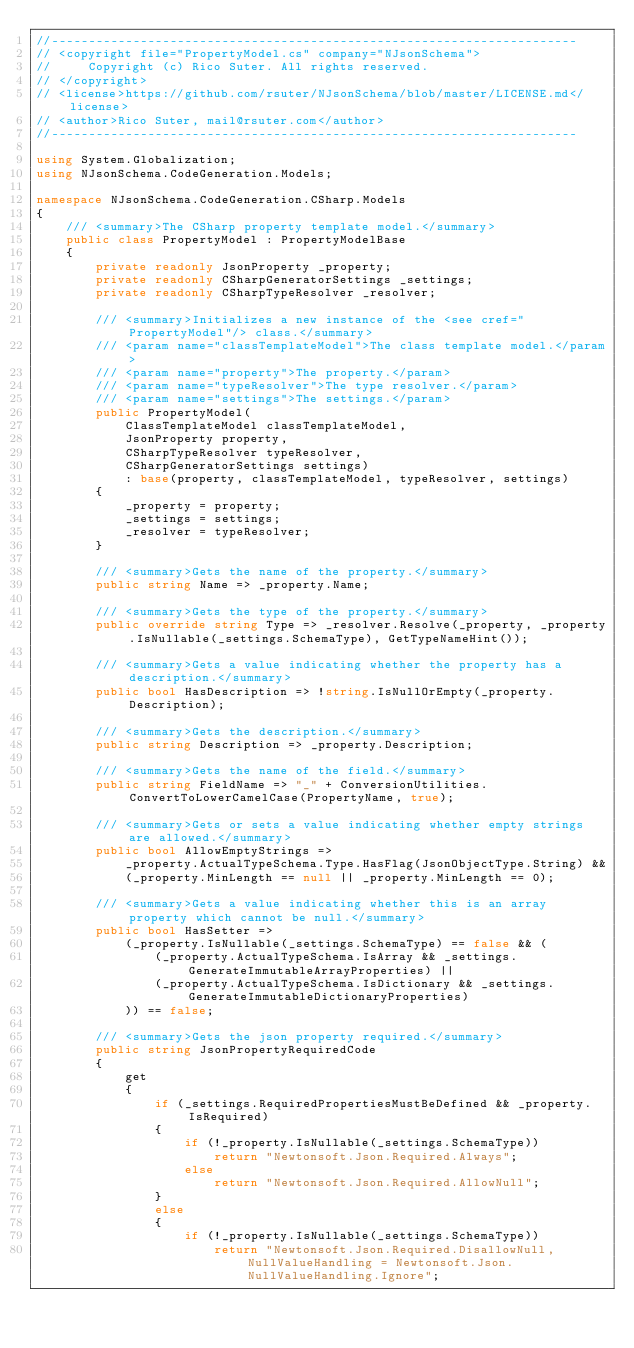<code> <loc_0><loc_0><loc_500><loc_500><_C#_>//-----------------------------------------------------------------------
// <copyright file="PropertyModel.cs" company="NJsonSchema">
//     Copyright (c) Rico Suter. All rights reserved.
// </copyright>
// <license>https://github.com/rsuter/NJsonSchema/blob/master/LICENSE.md</license>
// <author>Rico Suter, mail@rsuter.com</author>
//-----------------------------------------------------------------------

using System.Globalization;
using NJsonSchema.CodeGeneration.Models;

namespace NJsonSchema.CodeGeneration.CSharp.Models
{
    /// <summary>The CSharp property template model.</summary>
    public class PropertyModel : PropertyModelBase
    {
        private readonly JsonProperty _property;
        private readonly CSharpGeneratorSettings _settings;
        private readonly CSharpTypeResolver _resolver;

        /// <summary>Initializes a new instance of the <see cref="PropertyModel"/> class.</summary>
        /// <param name="classTemplateModel">The class template model.</param>
        /// <param name="property">The property.</param>
        /// <param name="typeResolver">The type resolver.</param>
        /// <param name="settings">The settings.</param>
        public PropertyModel(
            ClassTemplateModel classTemplateModel,
            JsonProperty property,
            CSharpTypeResolver typeResolver,
            CSharpGeneratorSettings settings)
            : base(property, classTemplateModel, typeResolver, settings)
        {
            _property = property;
            _settings = settings;
            _resolver = typeResolver;
        }

        /// <summary>Gets the name of the property.</summary>
        public string Name => _property.Name;

        /// <summary>Gets the type of the property.</summary>
        public override string Type => _resolver.Resolve(_property, _property.IsNullable(_settings.SchemaType), GetTypeNameHint());

        /// <summary>Gets a value indicating whether the property has a description.</summary>
        public bool HasDescription => !string.IsNullOrEmpty(_property.Description);

        /// <summary>Gets the description.</summary>
        public string Description => _property.Description;

        /// <summary>Gets the name of the field.</summary>
        public string FieldName => "_" + ConversionUtilities.ConvertToLowerCamelCase(PropertyName, true);

        /// <summary>Gets or sets a value indicating whether empty strings are allowed.</summary>
        public bool AllowEmptyStrings =>
            _property.ActualTypeSchema.Type.HasFlag(JsonObjectType.String) &&
            (_property.MinLength == null || _property.MinLength == 0);

        /// <summary>Gets a value indicating whether this is an array property which cannot be null.</summary>
        public bool HasSetter =>
            (_property.IsNullable(_settings.SchemaType) == false && (
                (_property.ActualTypeSchema.IsArray && _settings.GenerateImmutableArrayProperties) ||
                (_property.ActualTypeSchema.IsDictionary && _settings.GenerateImmutableDictionaryProperties)
            )) == false;

        /// <summary>Gets the json property required.</summary>
        public string JsonPropertyRequiredCode
        {
            get
            {
                if (_settings.RequiredPropertiesMustBeDefined && _property.IsRequired)
                {
                    if (!_property.IsNullable(_settings.SchemaType))
                        return "Newtonsoft.Json.Required.Always";
                    else
                        return "Newtonsoft.Json.Required.AllowNull";
                }
                else
                {
                    if (!_property.IsNullable(_settings.SchemaType))
                        return "Newtonsoft.Json.Required.DisallowNull, NullValueHandling = Newtonsoft.Json.NullValueHandling.Ignore";</code> 